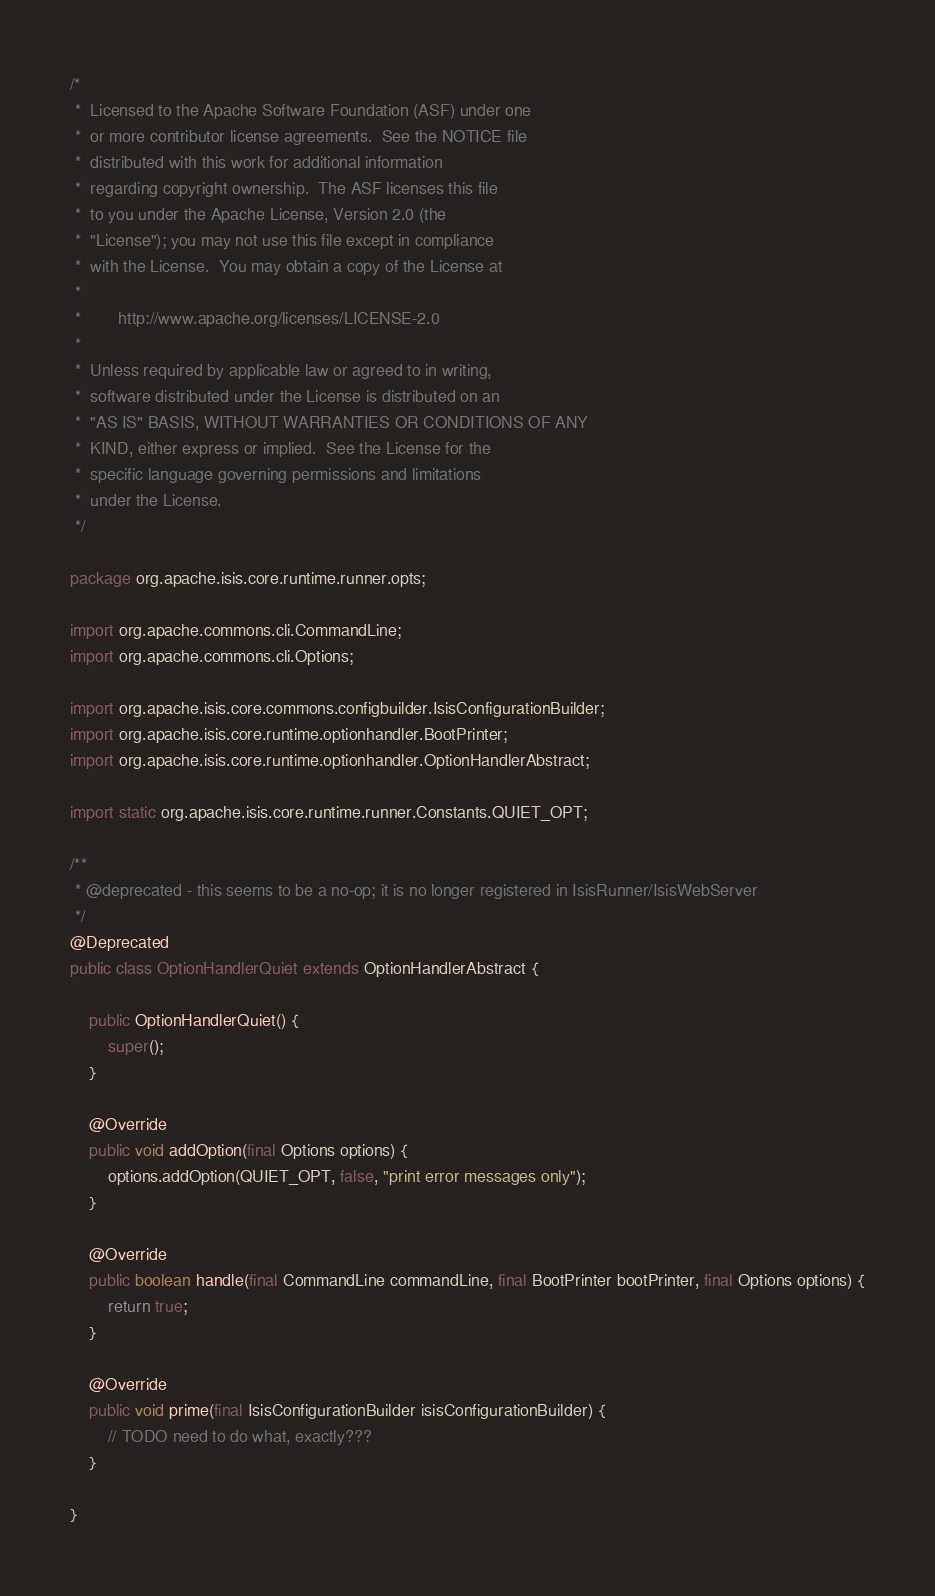<code> <loc_0><loc_0><loc_500><loc_500><_Java_>/*
 *  Licensed to the Apache Software Foundation (ASF) under one
 *  or more contributor license agreements.  See the NOTICE file
 *  distributed with this work for additional information
 *  regarding copyright ownership.  The ASF licenses this file
 *  to you under the Apache License, Version 2.0 (the
 *  "License"); you may not use this file except in compliance
 *  with the License.  You may obtain a copy of the License at
 *
 *        http://www.apache.org/licenses/LICENSE-2.0
 *
 *  Unless required by applicable law or agreed to in writing,
 *  software distributed under the License is distributed on an
 *  "AS IS" BASIS, WITHOUT WARRANTIES OR CONDITIONS OF ANY
 *  KIND, either express or implied.  See the License for the
 *  specific language governing permissions and limitations
 *  under the License.
 */

package org.apache.isis.core.runtime.runner.opts;

import org.apache.commons.cli.CommandLine;
import org.apache.commons.cli.Options;

import org.apache.isis.core.commons.configbuilder.IsisConfigurationBuilder;
import org.apache.isis.core.runtime.optionhandler.BootPrinter;
import org.apache.isis.core.runtime.optionhandler.OptionHandlerAbstract;

import static org.apache.isis.core.runtime.runner.Constants.QUIET_OPT;

/**
 * @deprecated - this seems to be a no-op; it is no longer registered in IsisRunner/IsisWebServer
 */
@Deprecated
public class OptionHandlerQuiet extends OptionHandlerAbstract {

    public OptionHandlerQuiet() {
        super();
    }

    @Override
    public void addOption(final Options options) {
        options.addOption(QUIET_OPT, false, "print error messages only");
    }

    @Override
    public boolean handle(final CommandLine commandLine, final BootPrinter bootPrinter, final Options options) {
        return true;
    }

    @Override
    public void prime(final IsisConfigurationBuilder isisConfigurationBuilder) {
        // TODO need to do what, exactly???
    }

}
</code> 